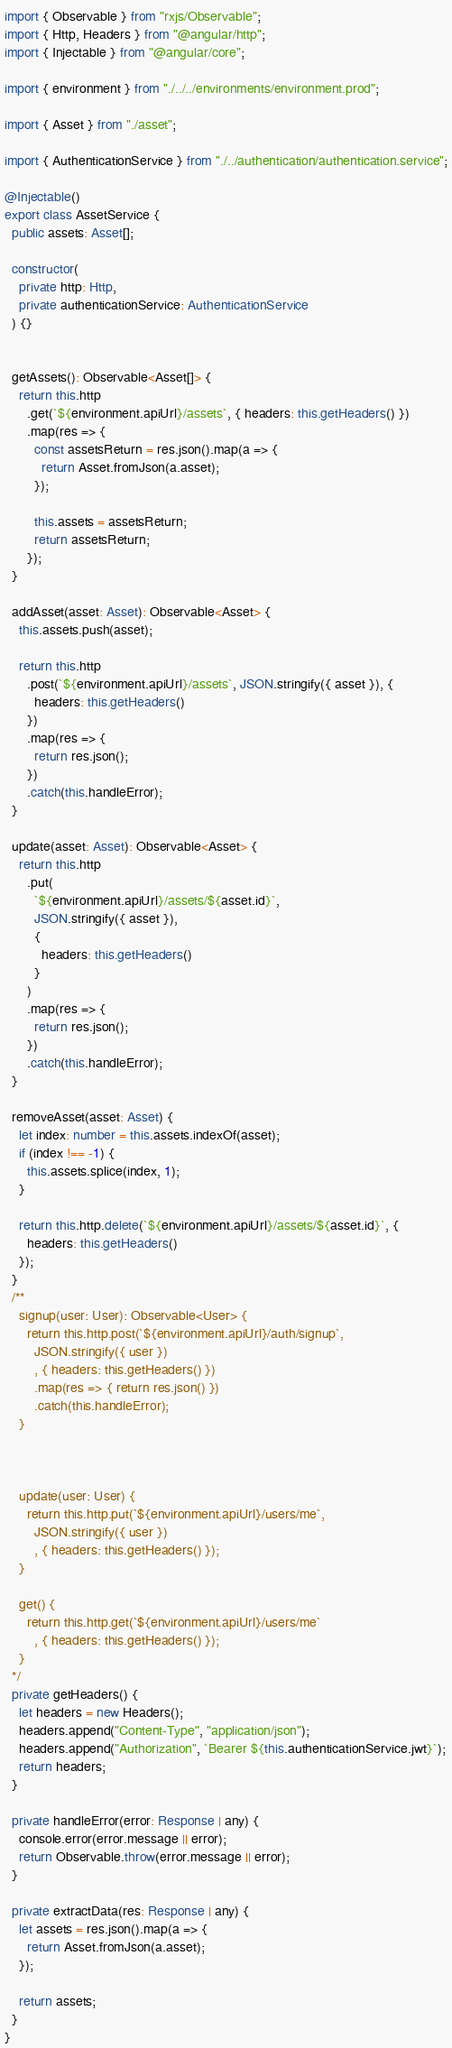Convert code to text. <code><loc_0><loc_0><loc_500><loc_500><_TypeScript_>import { Observable } from "rxjs/Observable";
import { Http, Headers } from "@angular/http";
import { Injectable } from "@angular/core";

import { environment } from "./../../environments/environment.prod";

import { Asset } from "./asset";

import { AuthenticationService } from "./../authentication/authentication.service";

@Injectable()
export class AssetService {
  public assets: Asset[];

  constructor(
    private http: Http,
    private authenticationService: AuthenticationService
  ) {}


  getAssets(): Observable<Asset[]> {
    return this.http
      .get(`${environment.apiUrl}/assets`, { headers: this.getHeaders() })
      .map(res => {
        const assetsReturn = res.json().map(a => {
          return Asset.fromJson(a.asset);
        });

        this.assets = assetsReturn;
        return assetsReturn;
      });
  }

  addAsset(asset: Asset): Observable<Asset> {
    this.assets.push(asset);

    return this.http
      .post(`${environment.apiUrl}/assets`, JSON.stringify({ asset }), {
        headers: this.getHeaders()
      })
      .map(res => {
        return res.json();
      })
      .catch(this.handleError);
  }

  update(asset: Asset): Observable<Asset> {
    return this.http
      .put(
        `${environment.apiUrl}/assets/${asset.id}`,
        JSON.stringify({ asset }),
        {
          headers: this.getHeaders()
        }
      )
      .map(res => {
        return res.json();
      })
      .catch(this.handleError);
  }

  removeAsset(asset: Asset) {
    let index: number = this.assets.indexOf(asset);
    if (index !== -1) {
      this.assets.splice(index, 1);
    }

    return this.http.delete(`${environment.apiUrl}/assets/${asset.id}`, {
      headers: this.getHeaders()
    });
  }
  /**
    signup(user: User): Observable<User> {
      return this.http.post(`${environment.apiUrl}/auth/signup`,
        JSON.stringify({ user })
        , { headers: this.getHeaders() })
        .map(res => { return res.json() })
        .catch(this.handleError);
    }



    update(user: User) {
      return this.http.put(`${environment.apiUrl}/users/me`,
        JSON.stringify({ user })
        , { headers: this.getHeaders() });
    }

    get() {
      return this.http.get(`${environment.apiUrl}/users/me`
        , { headers: this.getHeaders() });
    }
  */
  private getHeaders() {
    let headers = new Headers();
    headers.append("Content-Type", "application/json");
    headers.append("Authorization", `Bearer ${this.authenticationService.jwt}`);
    return headers;
  }

  private handleError(error: Response | any) {
    console.error(error.message || error);
    return Observable.throw(error.message || error);
  }

  private extractData(res: Response | any) {
    let assets = res.json().map(a => {
      return Asset.fromJson(a.asset);
    });

    return assets;
  }
}
</code> 